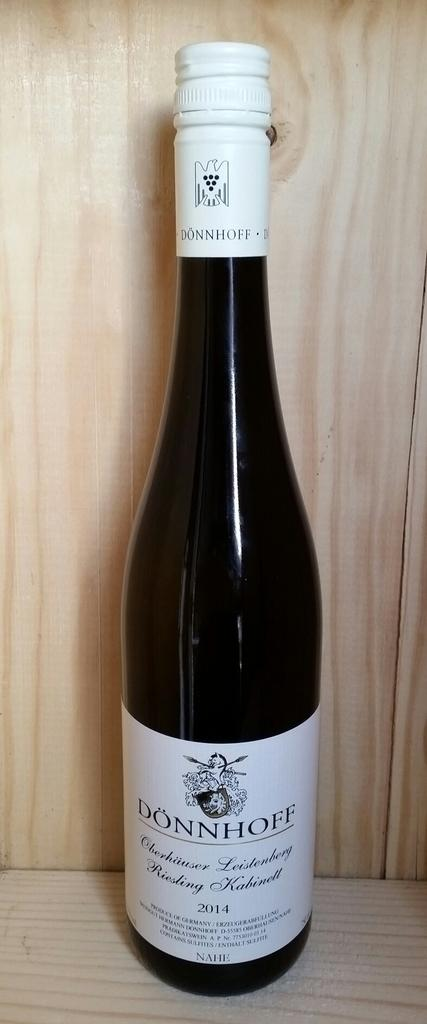What object can be seen in the image? There is a bottle in the image. What is the color of the bottle? The bottle is black in color. What type of bottle does it resemble? The bottle resembles a wine bottle. What type of popcorn is being served in the image? There is no popcorn present in the image; it only features a black bottle that resembles a wine bottle. 